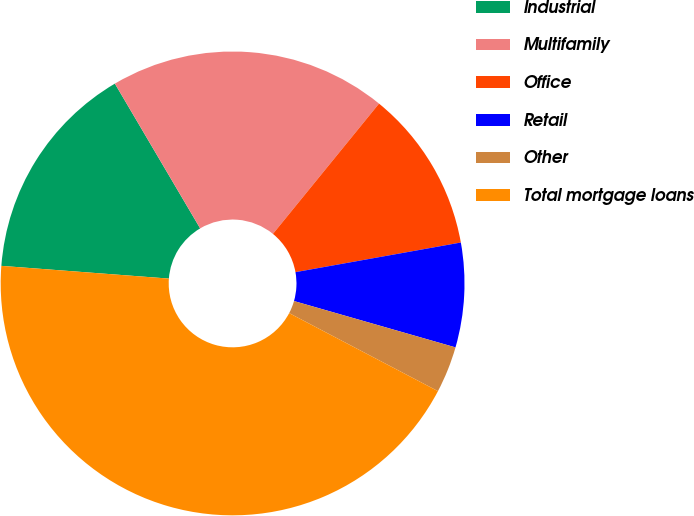<chart> <loc_0><loc_0><loc_500><loc_500><pie_chart><fcel>Industrial<fcel>Multifamily<fcel>Office<fcel>Retail<fcel>Other<fcel>Total mortgage loans<nl><fcel>15.32%<fcel>19.35%<fcel>11.3%<fcel>7.27%<fcel>3.24%<fcel>43.52%<nl></chart> 